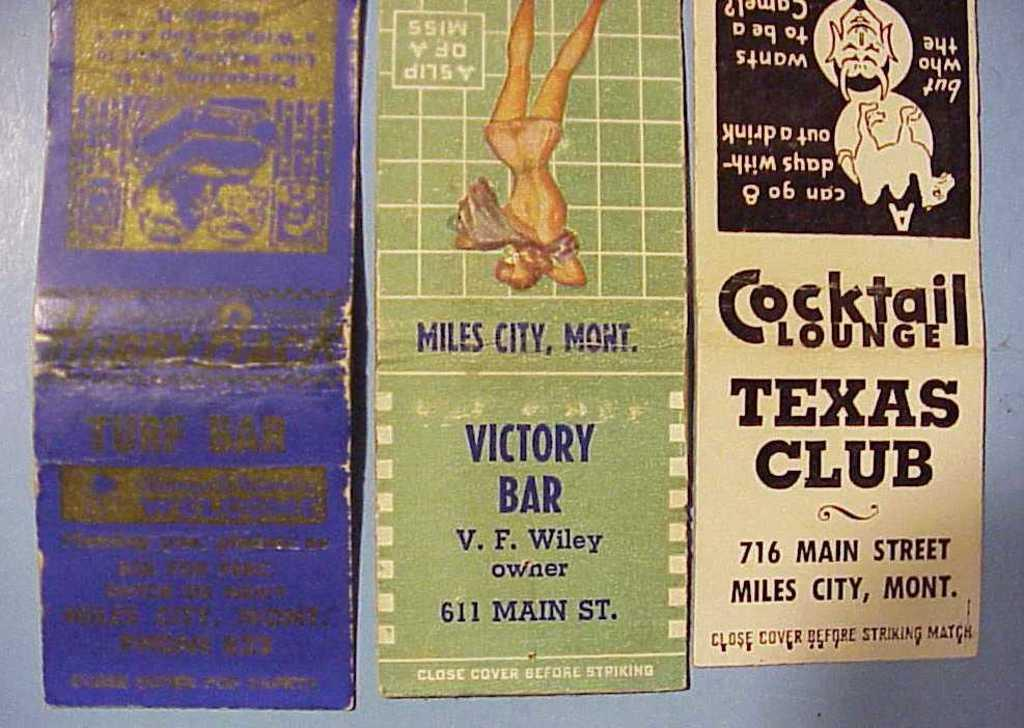<image>
Describe the image concisely. Matchbooks are advertising places in Miles City, Montana. 